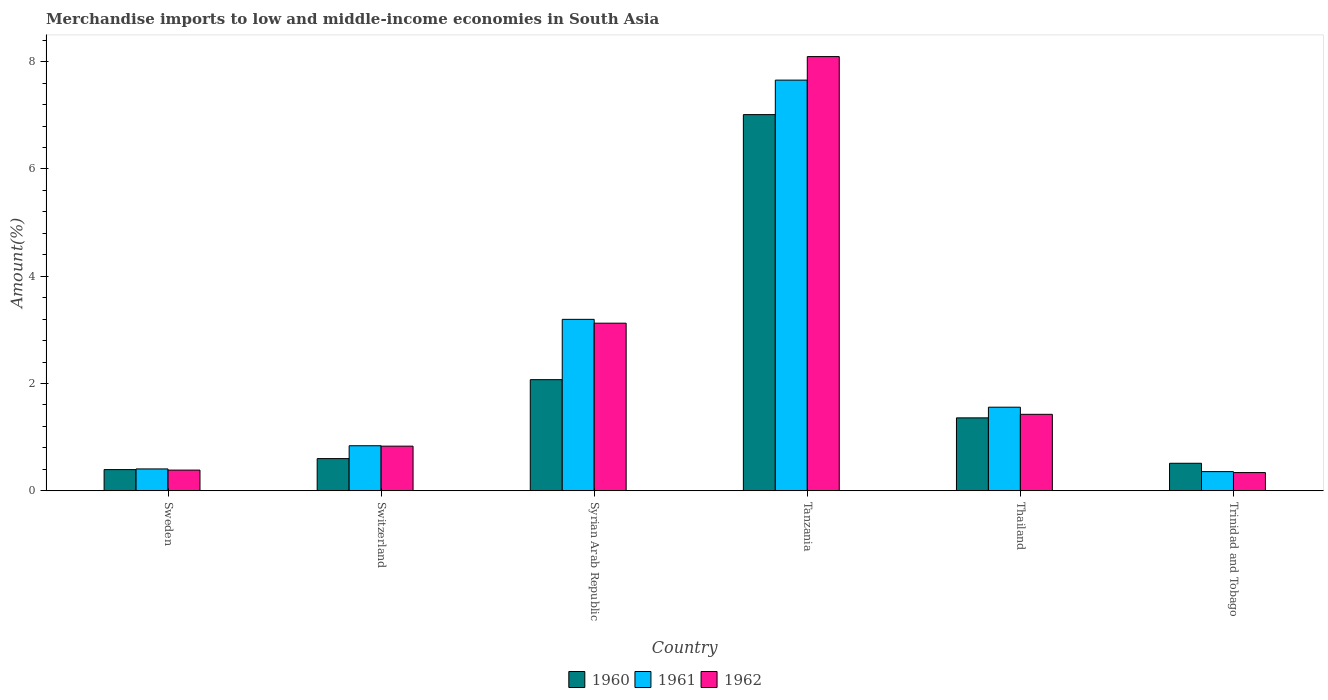How many groups of bars are there?
Your answer should be very brief. 6. How many bars are there on the 3rd tick from the right?
Your response must be concise. 3. What is the label of the 5th group of bars from the left?
Offer a terse response. Thailand. In how many cases, is the number of bars for a given country not equal to the number of legend labels?
Provide a succinct answer. 0. What is the percentage of amount earned from merchandise imports in 1962 in Sweden?
Your answer should be very brief. 0.39. Across all countries, what is the maximum percentage of amount earned from merchandise imports in 1962?
Keep it short and to the point. 8.1. Across all countries, what is the minimum percentage of amount earned from merchandise imports in 1960?
Your answer should be very brief. 0.39. In which country was the percentage of amount earned from merchandise imports in 1962 maximum?
Your answer should be very brief. Tanzania. In which country was the percentage of amount earned from merchandise imports in 1961 minimum?
Your answer should be compact. Trinidad and Tobago. What is the total percentage of amount earned from merchandise imports in 1962 in the graph?
Your response must be concise. 14.2. What is the difference between the percentage of amount earned from merchandise imports in 1960 in Syrian Arab Republic and that in Tanzania?
Offer a very short reply. -4.94. What is the difference between the percentage of amount earned from merchandise imports in 1962 in Syrian Arab Republic and the percentage of amount earned from merchandise imports in 1960 in Thailand?
Provide a succinct answer. 1.77. What is the average percentage of amount earned from merchandise imports in 1961 per country?
Make the answer very short. 2.34. What is the difference between the percentage of amount earned from merchandise imports of/in 1962 and percentage of amount earned from merchandise imports of/in 1960 in Syrian Arab Republic?
Your response must be concise. 1.05. In how many countries, is the percentage of amount earned from merchandise imports in 1962 greater than 4 %?
Offer a very short reply. 1. What is the ratio of the percentage of amount earned from merchandise imports in 1960 in Tanzania to that in Trinidad and Tobago?
Provide a short and direct response. 13.67. What is the difference between the highest and the second highest percentage of amount earned from merchandise imports in 1961?
Ensure brevity in your answer.  -1.64. What is the difference between the highest and the lowest percentage of amount earned from merchandise imports in 1962?
Your answer should be compact. 7.76. Is the sum of the percentage of amount earned from merchandise imports in 1961 in Tanzania and Trinidad and Tobago greater than the maximum percentage of amount earned from merchandise imports in 1960 across all countries?
Ensure brevity in your answer.  Yes. What does the 2nd bar from the left in Tanzania represents?
Give a very brief answer. 1961. Is it the case that in every country, the sum of the percentage of amount earned from merchandise imports in 1960 and percentage of amount earned from merchandise imports in 1962 is greater than the percentage of amount earned from merchandise imports in 1961?
Offer a very short reply. Yes. Are all the bars in the graph horizontal?
Give a very brief answer. No. How many countries are there in the graph?
Your answer should be very brief. 6. Are the values on the major ticks of Y-axis written in scientific E-notation?
Your response must be concise. No. How many legend labels are there?
Offer a very short reply. 3. How are the legend labels stacked?
Make the answer very short. Horizontal. What is the title of the graph?
Provide a short and direct response. Merchandise imports to low and middle-income economies in South Asia. Does "1985" appear as one of the legend labels in the graph?
Your answer should be compact. No. What is the label or title of the X-axis?
Provide a short and direct response. Country. What is the label or title of the Y-axis?
Your answer should be compact. Amount(%). What is the Amount(%) of 1960 in Sweden?
Make the answer very short. 0.39. What is the Amount(%) in 1961 in Sweden?
Your answer should be very brief. 0.41. What is the Amount(%) in 1962 in Sweden?
Your response must be concise. 0.39. What is the Amount(%) of 1960 in Switzerland?
Your answer should be compact. 0.6. What is the Amount(%) of 1961 in Switzerland?
Ensure brevity in your answer.  0.84. What is the Amount(%) in 1962 in Switzerland?
Ensure brevity in your answer.  0.83. What is the Amount(%) of 1960 in Syrian Arab Republic?
Keep it short and to the point. 2.07. What is the Amount(%) of 1961 in Syrian Arab Republic?
Your response must be concise. 3.2. What is the Amount(%) in 1962 in Syrian Arab Republic?
Give a very brief answer. 3.12. What is the Amount(%) of 1960 in Tanzania?
Provide a short and direct response. 7.01. What is the Amount(%) in 1961 in Tanzania?
Provide a short and direct response. 7.66. What is the Amount(%) in 1962 in Tanzania?
Keep it short and to the point. 8.1. What is the Amount(%) of 1960 in Thailand?
Your response must be concise. 1.36. What is the Amount(%) in 1961 in Thailand?
Keep it short and to the point. 1.56. What is the Amount(%) in 1962 in Thailand?
Ensure brevity in your answer.  1.43. What is the Amount(%) of 1960 in Trinidad and Tobago?
Provide a succinct answer. 0.51. What is the Amount(%) of 1961 in Trinidad and Tobago?
Keep it short and to the point. 0.36. What is the Amount(%) of 1962 in Trinidad and Tobago?
Your answer should be compact. 0.34. Across all countries, what is the maximum Amount(%) of 1960?
Keep it short and to the point. 7.01. Across all countries, what is the maximum Amount(%) in 1961?
Provide a short and direct response. 7.66. Across all countries, what is the maximum Amount(%) in 1962?
Your answer should be compact. 8.1. Across all countries, what is the minimum Amount(%) in 1960?
Your response must be concise. 0.39. Across all countries, what is the minimum Amount(%) of 1961?
Your answer should be very brief. 0.36. Across all countries, what is the minimum Amount(%) in 1962?
Offer a very short reply. 0.34. What is the total Amount(%) of 1960 in the graph?
Your response must be concise. 11.95. What is the total Amount(%) of 1961 in the graph?
Ensure brevity in your answer.  14.02. What is the total Amount(%) of 1962 in the graph?
Ensure brevity in your answer.  14.2. What is the difference between the Amount(%) of 1960 in Sweden and that in Switzerland?
Keep it short and to the point. -0.2. What is the difference between the Amount(%) in 1961 in Sweden and that in Switzerland?
Make the answer very short. -0.43. What is the difference between the Amount(%) in 1962 in Sweden and that in Switzerland?
Your response must be concise. -0.45. What is the difference between the Amount(%) of 1960 in Sweden and that in Syrian Arab Republic?
Your response must be concise. -1.68. What is the difference between the Amount(%) in 1961 in Sweden and that in Syrian Arab Republic?
Give a very brief answer. -2.79. What is the difference between the Amount(%) in 1962 in Sweden and that in Syrian Arab Republic?
Offer a terse response. -2.74. What is the difference between the Amount(%) of 1960 in Sweden and that in Tanzania?
Your response must be concise. -6.62. What is the difference between the Amount(%) in 1961 in Sweden and that in Tanzania?
Your answer should be compact. -7.25. What is the difference between the Amount(%) in 1962 in Sweden and that in Tanzania?
Ensure brevity in your answer.  -7.71. What is the difference between the Amount(%) of 1960 in Sweden and that in Thailand?
Offer a terse response. -0.96. What is the difference between the Amount(%) of 1961 in Sweden and that in Thailand?
Offer a very short reply. -1.15. What is the difference between the Amount(%) of 1962 in Sweden and that in Thailand?
Give a very brief answer. -1.04. What is the difference between the Amount(%) in 1960 in Sweden and that in Trinidad and Tobago?
Keep it short and to the point. -0.12. What is the difference between the Amount(%) in 1961 in Sweden and that in Trinidad and Tobago?
Keep it short and to the point. 0.05. What is the difference between the Amount(%) of 1962 in Sweden and that in Trinidad and Tobago?
Provide a short and direct response. 0.05. What is the difference between the Amount(%) in 1960 in Switzerland and that in Syrian Arab Republic?
Offer a terse response. -1.47. What is the difference between the Amount(%) of 1961 in Switzerland and that in Syrian Arab Republic?
Ensure brevity in your answer.  -2.36. What is the difference between the Amount(%) of 1962 in Switzerland and that in Syrian Arab Republic?
Provide a succinct answer. -2.29. What is the difference between the Amount(%) of 1960 in Switzerland and that in Tanzania?
Your answer should be very brief. -6.41. What is the difference between the Amount(%) in 1961 in Switzerland and that in Tanzania?
Make the answer very short. -6.82. What is the difference between the Amount(%) of 1962 in Switzerland and that in Tanzania?
Give a very brief answer. -7.26. What is the difference between the Amount(%) in 1960 in Switzerland and that in Thailand?
Ensure brevity in your answer.  -0.76. What is the difference between the Amount(%) of 1961 in Switzerland and that in Thailand?
Give a very brief answer. -0.72. What is the difference between the Amount(%) in 1962 in Switzerland and that in Thailand?
Ensure brevity in your answer.  -0.59. What is the difference between the Amount(%) in 1960 in Switzerland and that in Trinidad and Tobago?
Give a very brief answer. 0.09. What is the difference between the Amount(%) in 1961 in Switzerland and that in Trinidad and Tobago?
Your answer should be very brief. 0.48. What is the difference between the Amount(%) in 1962 in Switzerland and that in Trinidad and Tobago?
Provide a succinct answer. 0.49. What is the difference between the Amount(%) in 1960 in Syrian Arab Republic and that in Tanzania?
Offer a terse response. -4.94. What is the difference between the Amount(%) of 1961 in Syrian Arab Republic and that in Tanzania?
Your answer should be very brief. -4.46. What is the difference between the Amount(%) of 1962 in Syrian Arab Republic and that in Tanzania?
Provide a succinct answer. -4.97. What is the difference between the Amount(%) in 1960 in Syrian Arab Republic and that in Thailand?
Provide a short and direct response. 0.71. What is the difference between the Amount(%) of 1961 in Syrian Arab Republic and that in Thailand?
Keep it short and to the point. 1.64. What is the difference between the Amount(%) of 1962 in Syrian Arab Republic and that in Thailand?
Offer a terse response. 1.7. What is the difference between the Amount(%) of 1960 in Syrian Arab Republic and that in Trinidad and Tobago?
Give a very brief answer. 1.56. What is the difference between the Amount(%) in 1961 in Syrian Arab Republic and that in Trinidad and Tobago?
Your answer should be compact. 2.84. What is the difference between the Amount(%) of 1962 in Syrian Arab Republic and that in Trinidad and Tobago?
Make the answer very short. 2.79. What is the difference between the Amount(%) in 1960 in Tanzania and that in Thailand?
Make the answer very short. 5.65. What is the difference between the Amount(%) in 1961 in Tanzania and that in Thailand?
Make the answer very short. 6.1. What is the difference between the Amount(%) of 1962 in Tanzania and that in Thailand?
Make the answer very short. 6.67. What is the difference between the Amount(%) in 1960 in Tanzania and that in Trinidad and Tobago?
Make the answer very short. 6.5. What is the difference between the Amount(%) in 1961 in Tanzania and that in Trinidad and Tobago?
Your response must be concise. 7.3. What is the difference between the Amount(%) of 1962 in Tanzania and that in Trinidad and Tobago?
Provide a short and direct response. 7.76. What is the difference between the Amount(%) of 1960 in Thailand and that in Trinidad and Tobago?
Your response must be concise. 0.85. What is the difference between the Amount(%) in 1961 in Thailand and that in Trinidad and Tobago?
Give a very brief answer. 1.2. What is the difference between the Amount(%) of 1962 in Thailand and that in Trinidad and Tobago?
Keep it short and to the point. 1.09. What is the difference between the Amount(%) of 1960 in Sweden and the Amount(%) of 1961 in Switzerland?
Offer a terse response. -0.44. What is the difference between the Amount(%) of 1960 in Sweden and the Amount(%) of 1962 in Switzerland?
Provide a short and direct response. -0.44. What is the difference between the Amount(%) in 1961 in Sweden and the Amount(%) in 1962 in Switzerland?
Your response must be concise. -0.42. What is the difference between the Amount(%) in 1960 in Sweden and the Amount(%) in 1961 in Syrian Arab Republic?
Your answer should be very brief. -2.8. What is the difference between the Amount(%) of 1960 in Sweden and the Amount(%) of 1962 in Syrian Arab Republic?
Your response must be concise. -2.73. What is the difference between the Amount(%) in 1961 in Sweden and the Amount(%) in 1962 in Syrian Arab Republic?
Keep it short and to the point. -2.72. What is the difference between the Amount(%) in 1960 in Sweden and the Amount(%) in 1961 in Tanzania?
Provide a short and direct response. -7.26. What is the difference between the Amount(%) in 1960 in Sweden and the Amount(%) in 1962 in Tanzania?
Offer a very short reply. -7.7. What is the difference between the Amount(%) in 1961 in Sweden and the Amount(%) in 1962 in Tanzania?
Your answer should be very brief. -7.69. What is the difference between the Amount(%) of 1960 in Sweden and the Amount(%) of 1961 in Thailand?
Your response must be concise. -1.16. What is the difference between the Amount(%) of 1960 in Sweden and the Amount(%) of 1962 in Thailand?
Give a very brief answer. -1.03. What is the difference between the Amount(%) in 1961 in Sweden and the Amount(%) in 1962 in Thailand?
Offer a very short reply. -1.02. What is the difference between the Amount(%) in 1960 in Sweden and the Amount(%) in 1961 in Trinidad and Tobago?
Make the answer very short. 0.04. What is the difference between the Amount(%) in 1960 in Sweden and the Amount(%) in 1962 in Trinidad and Tobago?
Provide a short and direct response. 0.06. What is the difference between the Amount(%) in 1961 in Sweden and the Amount(%) in 1962 in Trinidad and Tobago?
Keep it short and to the point. 0.07. What is the difference between the Amount(%) of 1960 in Switzerland and the Amount(%) of 1961 in Syrian Arab Republic?
Ensure brevity in your answer.  -2.6. What is the difference between the Amount(%) in 1960 in Switzerland and the Amount(%) in 1962 in Syrian Arab Republic?
Provide a short and direct response. -2.52. What is the difference between the Amount(%) in 1961 in Switzerland and the Amount(%) in 1962 in Syrian Arab Republic?
Provide a short and direct response. -2.29. What is the difference between the Amount(%) of 1960 in Switzerland and the Amount(%) of 1961 in Tanzania?
Provide a succinct answer. -7.06. What is the difference between the Amount(%) of 1960 in Switzerland and the Amount(%) of 1962 in Tanzania?
Make the answer very short. -7.5. What is the difference between the Amount(%) of 1961 in Switzerland and the Amount(%) of 1962 in Tanzania?
Your answer should be very brief. -7.26. What is the difference between the Amount(%) of 1960 in Switzerland and the Amount(%) of 1961 in Thailand?
Offer a very short reply. -0.96. What is the difference between the Amount(%) of 1960 in Switzerland and the Amount(%) of 1962 in Thailand?
Provide a short and direct response. -0.83. What is the difference between the Amount(%) of 1961 in Switzerland and the Amount(%) of 1962 in Thailand?
Offer a terse response. -0.59. What is the difference between the Amount(%) of 1960 in Switzerland and the Amount(%) of 1961 in Trinidad and Tobago?
Make the answer very short. 0.24. What is the difference between the Amount(%) in 1960 in Switzerland and the Amount(%) in 1962 in Trinidad and Tobago?
Make the answer very short. 0.26. What is the difference between the Amount(%) of 1961 in Switzerland and the Amount(%) of 1962 in Trinidad and Tobago?
Ensure brevity in your answer.  0.5. What is the difference between the Amount(%) in 1960 in Syrian Arab Republic and the Amount(%) in 1961 in Tanzania?
Keep it short and to the point. -5.58. What is the difference between the Amount(%) in 1960 in Syrian Arab Republic and the Amount(%) in 1962 in Tanzania?
Offer a terse response. -6.02. What is the difference between the Amount(%) of 1961 in Syrian Arab Republic and the Amount(%) of 1962 in Tanzania?
Your answer should be very brief. -4.9. What is the difference between the Amount(%) of 1960 in Syrian Arab Republic and the Amount(%) of 1961 in Thailand?
Offer a terse response. 0.51. What is the difference between the Amount(%) in 1960 in Syrian Arab Republic and the Amount(%) in 1962 in Thailand?
Your answer should be compact. 0.65. What is the difference between the Amount(%) of 1961 in Syrian Arab Republic and the Amount(%) of 1962 in Thailand?
Ensure brevity in your answer.  1.77. What is the difference between the Amount(%) in 1960 in Syrian Arab Republic and the Amount(%) in 1961 in Trinidad and Tobago?
Your answer should be very brief. 1.71. What is the difference between the Amount(%) in 1960 in Syrian Arab Republic and the Amount(%) in 1962 in Trinidad and Tobago?
Your answer should be very brief. 1.73. What is the difference between the Amount(%) in 1961 in Syrian Arab Republic and the Amount(%) in 1962 in Trinidad and Tobago?
Offer a very short reply. 2.86. What is the difference between the Amount(%) of 1960 in Tanzania and the Amount(%) of 1961 in Thailand?
Ensure brevity in your answer.  5.45. What is the difference between the Amount(%) in 1960 in Tanzania and the Amount(%) in 1962 in Thailand?
Your response must be concise. 5.59. What is the difference between the Amount(%) of 1961 in Tanzania and the Amount(%) of 1962 in Thailand?
Offer a terse response. 6.23. What is the difference between the Amount(%) of 1960 in Tanzania and the Amount(%) of 1961 in Trinidad and Tobago?
Give a very brief answer. 6.66. What is the difference between the Amount(%) in 1960 in Tanzania and the Amount(%) in 1962 in Trinidad and Tobago?
Your response must be concise. 6.67. What is the difference between the Amount(%) in 1961 in Tanzania and the Amount(%) in 1962 in Trinidad and Tobago?
Provide a succinct answer. 7.32. What is the difference between the Amount(%) of 1960 in Thailand and the Amount(%) of 1961 in Trinidad and Tobago?
Give a very brief answer. 1. What is the difference between the Amount(%) in 1960 in Thailand and the Amount(%) in 1962 in Trinidad and Tobago?
Ensure brevity in your answer.  1.02. What is the difference between the Amount(%) of 1961 in Thailand and the Amount(%) of 1962 in Trinidad and Tobago?
Ensure brevity in your answer.  1.22. What is the average Amount(%) in 1960 per country?
Ensure brevity in your answer.  1.99. What is the average Amount(%) of 1961 per country?
Provide a succinct answer. 2.34. What is the average Amount(%) in 1962 per country?
Ensure brevity in your answer.  2.37. What is the difference between the Amount(%) in 1960 and Amount(%) in 1961 in Sweden?
Offer a very short reply. -0.01. What is the difference between the Amount(%) of 1960 and Amount(%) of 1962 in Sweden?
Make the answer very short. 0.01. What is the difference between the Amount(%) in 1961 and Amount(%) in 1962 in Sweden?
Ensure brevity in your answer.  0.02. What is the difference between the Amount(%) in 1960 and Amount(%) in 1961 in Switzerland?
Ensure brevity in your answer.  -0.24. What is the difference between the Amount(%) of 1960 and Amount(%) of 1962 in Switzerland?
Your answer should be compact. -0.23. What is the difference between the Amount(%) of 1961 and Amount(%) of 1962 in Switzerland?
Your answer should be very brief. 0.01. What is the difference between the Amount(%) of 1960 and Amount(%) of 1961 in Syrian Arab Republic?
Provide a short and direct response. -1.12. What is the difference between the Amount(%) of 1960 and Amount(%) of 1962 in Syrian Arab Republic?
Give a very brief answer. -1.05. What is the difference between the Amount(%) of 1961 and Amount(%) of 1962 in Syrian Arab Republic?
Your answer should be compact. 0.07. What is the difference between the Amount(%) of 1960 and Amount(%) of 1961 in Tanzania?
Keep it short and to the point. -0.64. What is the difference between the Amount(%) in 1960 and Amount(%) in 1962 in Tanzania?
Keep it short and to the point. -1.08. What is the difference between the Amount(%) of 1961 and Amount(%) of 1962 in Tanzania?
Your response must be concise. -0.44. What is the difference between the Amount(%) in 1960 and Amount(%) in 1961 in Thailand?
Provide a short and direct response. -0.2. What is the difference between the Amount(%) in 1960 and Amount(%) in 1962 in Thailand?
Keep it short and to the point. -0.07. What is the difference between the Amount(%) in 1961 and Amount(%) in 1962 in Thailand?
Your response must be concise. 0.13. What is the difference between the Amount(%) of 1960 and Amount(%) of 1961 in Trinidad and Tobago?
Ensure brevity in your answer.  0.16. What is the difference between the Amount(%) of 1960 and Amount(%) of 1962 in Trinidad and Tobago?
Offer a terse response. 0.17. What is the difference between the Amount(%) in 1961 and Amount(%) in 1962 in Trinidad and Tobago?
Ensure brevity in your answer.  0.02. What is the ratio of the Amount(%) of 1960 in Sweden to that in Switzerland?
Your response must be concise. 0.66. What is the ratio of the Amount(%) in 1961 in Sweden to that in Switzerland?
Provide a short and direct response. 0.49. What is the ratio of the Amount(%) in 1962 in Sweden to that in Switzerland?
Ensure brevity in your answer.  0.46. What is the ratio of the Amount(%) of 1960 in Sweden to that in Syrian Arab Republic?
Your answer should be very brief. 0.19. What is the ratio of the Amount(%) in 1961 in Sweden to that in Syrian Arab Republic?
Provide a short and direct response. 0.13. What is the ratio of the Amount(%) of 1962 in Sweden to that in Syrian Arab Republic?
Ensure brevity in your answer.  0.12. What is the ratio of the Amount(%) in 1960 in Sweden to that in Tanzania?
Provide a succinct answer. 0.06. What is the ratio of the Amount(%) in 1961 in Sweden to that in Tanzania?
Ensure brevity in your answer.  0.05. What is the ratio of the Amount(%) of 1962 in Sweden to that in Tanzania?
Offer a very short reply. 0.05. What is the ratio of the Amount(%) in 1960 in Sweden to that in Thailand?
Keep it short and to the point. 0.29. What is the ratio of the Amount(%) of 1961 in Sweden to that in Thailand?
Your answer should be very brief. 0.26. What is the ratio of the Amount(%) of 1962 in Sweden to that in Thailand?
Your answer should be very brief. 0.27. What is the ratio of the Amount(%) in 1960 in Sweden to that in Trinidad and Tobago?
Keep it short and to the point. 0.77. What is the ratio of the Amount(%) in 1961 in Sweden to that in Trinidad and Tobago?
Your response must be concise. 1.14. What is the ratio of the Amount(%) of 1962 in Sweden to that in Trinidad and Tobago?
Make the answer very short. 1.14. What is the ratio of the Amount(%) in 1960 in Switzerland to that in Syrian Arab Republic?
Your response must be concise. 0.29. What is the ratio of the Amount(%) in 1961 in Switzerland to that in Syrian Arab Republic?
Your answer should be very brief. 0.26. What is the ratio of the Amount(%) in 1962 in Switzerland to that in Syrian Arab Republic?
Give a very brief answer. 0.27. What is the ratio of the Amount(%) of 1960 in Switzerland to that in Tanzania?
Ensure brevity in your answer.  0.09. What is the ratio of the Amount(%) in 1961 in Switzerland to that in Tanzania?
Provide a short and direct response. 0.11. What is the ratio of the Amount(%) in 1962 in Switzerland to that in Tanzania?
Ensure brevity in your answer.  0.1. What is the ratio of the Amount(%) in 1960 in Switzerland to that in Thailand?
Offer a very short reply. 0.44. What is the ratio of the Amount(%) of 1961 in Switzerland to that in Thailand?
Give a very brief answer. 0.54. What is the ratio of the Amount(%) in 1962 in Switzerland to that in Thailand?
Offer a very short reply. 0.58. What is the ratio of the Amount(%) of 1960 in Switzerland to that in Trinidad and Tobago?
Your answer should be very brief. 1.17. What is the ratio of the Amount(%) of 1961 in Switzerland to that in Trinidad and Tobago?
Provide a short and direct response. 2.35. What is the ratio of the Amount(%) in 1962 in Switzerland to that in Trinidad and Tobago?
Offer a terse response. 2.45. What is the ratio of the Amount(%) in 1960 in Syrian Arab Republic to that in Tanzania?
Offer a terse response. 0.3. What is the ratio of the Amount(%) of 1961 in Syrian Arab Republic to that in Tanzania?
Your response must be concise. 0.42. What is the ratio of the Amount(%) of 1962 in Syrian Arab Republic to that in Tanzania?
Give a very brief answer. 0.39. What is the ratio of the Amount(%) of 1960 in Syrian Arab Republic to that in Thailand?
Your answer should be very brief. 1.52. What is the ratio of the Amount(%) of 1961 in Syrian Arab Republic to that in Thailand?
Ensure brevity in your answer.  2.05. What is the ratio of the Amount(%) in 1962 in Syrian Arab Republic to that in Thailand?
Ensure brevity in your answer.  2.19. What is the ratio of the Amount(%) of 1960 in Syrian Arab Republic to that in Trinidad and Tobago?
Offer a very short reply. 4.04. What is the ratio of the Amount(%) in 1961 in Syrian Arab Republic to that in Trinidad and Tobago?
Keep it short and to the point. 8.94. What is the ratio of the Amount(%) of 1962 in Syrian Arab Republic to that in Trinidad and Tobago?
Your answer should be very brief. 9.2. What is the ratio of the Amount(%) of 1960 in Tanzania to that in Thailand?
Your answer should be very brief. 5.16. What is the ratio of the Amount(%) in 1961 in Tanzania to that in Thailand?
Give a very brief answer. 4.91. What is the ratio of the Amount(%) in 1962 in Tanzania to that in Thailand?
Offer a terse response. 5.68. What is the ratio of the Amount(%) in 1960 in Tanzania to that in Trinidad and Tobago?
Provide a succinct answer. 13.67. What is the ratio of the Amount(%) of 1961 in Tanzania to that in Trinidad and Tobago?
Your answer should be very brief. 21.42. What is the ratio of the Amount(%) of 1962 in Tanzania to that in Trinidad and Tobago?
Offer a terse response. 23.83. What is the ratio of the Amount(%) in 1960 in Thailand to that in Trinidad and Tobago?
Offer a very short reply. 2.65. What is the ratio of the Amount(%) of 1961 in Thailand to that in Trinidad and Tobago?
Make the answer very short. 4.36. What is the ratio of the Amount(%) in 1962 in Thailand to that in Trinidad and Tobago?
Provide a succinct answer. 4.2. What is the difference between the highest and the second highest Amount(%) in 1960?
Your response must be concise. 4.94. What is the difference between the highest and the second highest Amount(%) in 1961?
Keep it short and to the point. 4.46. What is the difference between the highest and the second highest Amount(%) in 1962?
Your answer should be compact. 4.97. What is the difference between the highest and the lowest Amount(%) in 1960?
Keep it short and to the point. 6.62. What is the difference between the highest and the lowest Amount(%) of 1961?
Your response must be concise. 7.3. What is the difference between the highest and the lowest Amount(%) in 1962?
Provide a short and direct response. 7.76. 